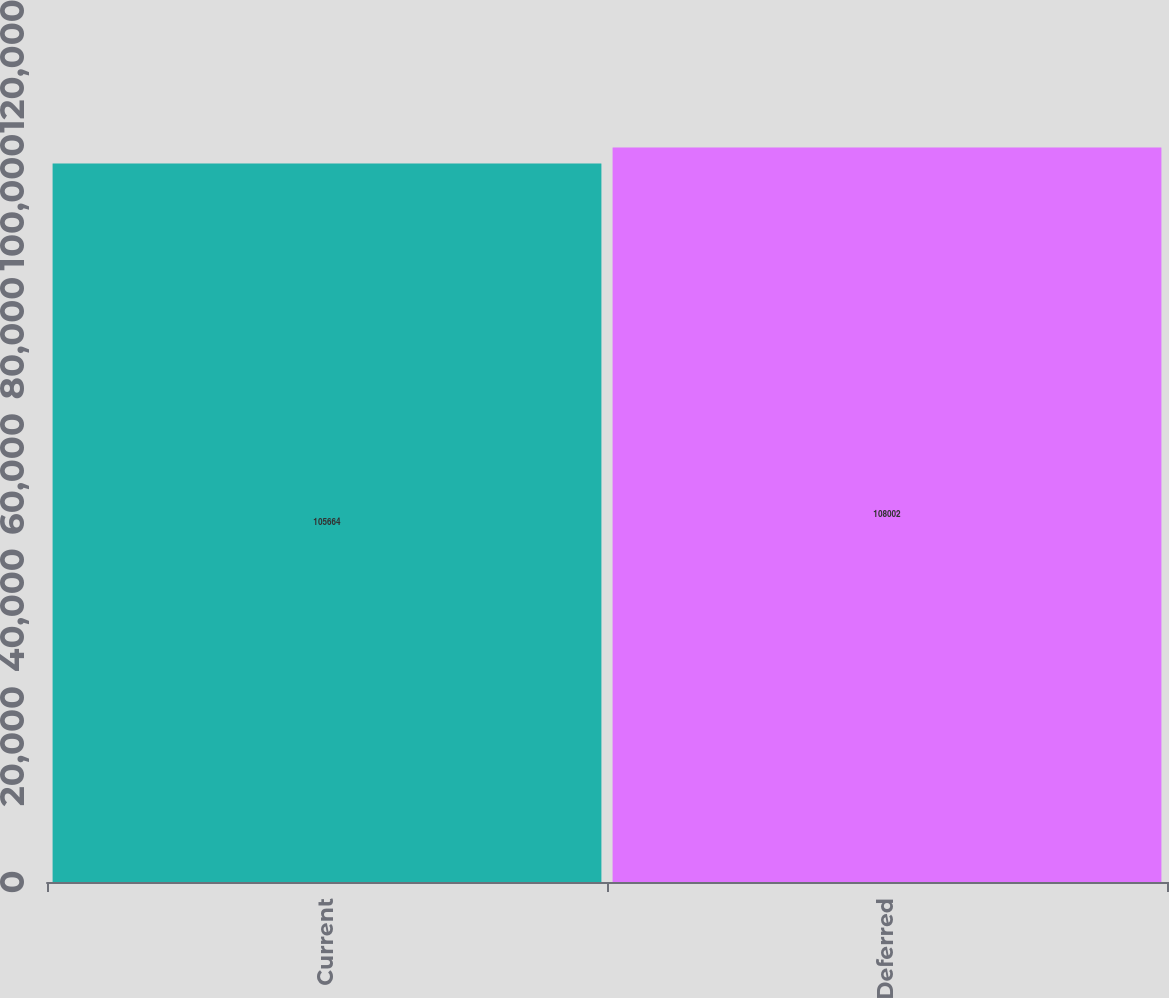<chart> <loc_0><loc_0><loc_500><loc_500><bar_chart><fcel>Current<fcel>Deferred<nl><fcel>105664<fcel>108002<nl></chart> 